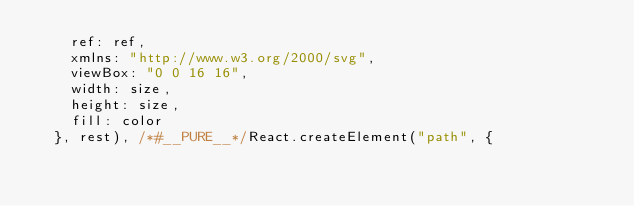<code> <loc_0><loc_0><loc_500><loc_500><_JavaScript_>    ref: ref,
    xmlns: "http://www.w3.org/2000/svg",
    viewBox: "0 0 16 16",
    width: size,
    height: size,
    fill: color
  }, rest), /*#__PURE__*/React.createElement("path", {</code> 